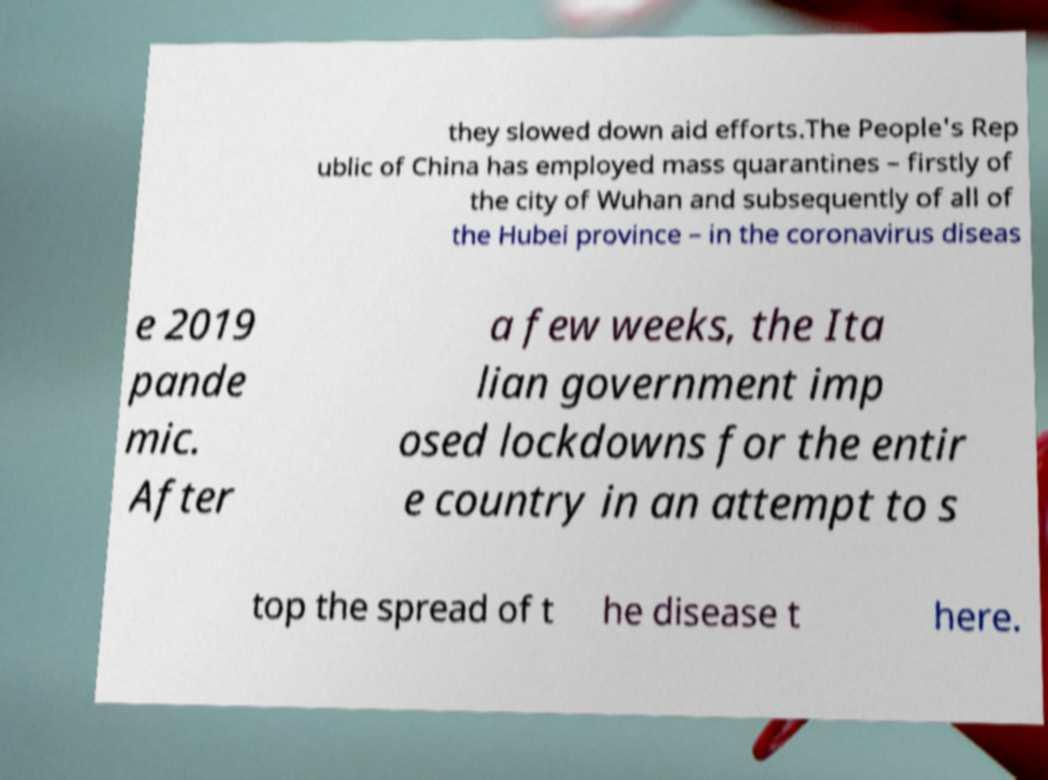I need the written content from this picture converted into text. Can you do that? they slowed down aid efforts.The People's Rep ublic of China has employed mass quarantines – firstly of the city of Wuhan and subsequently of all of the Hubei province – in the coronavirus diseas e 2019 pande mic. After a few weeks, the Ita lian government imp osed lockdowns for the entir e country in an attempt to s top the spread of t he disease t here. 